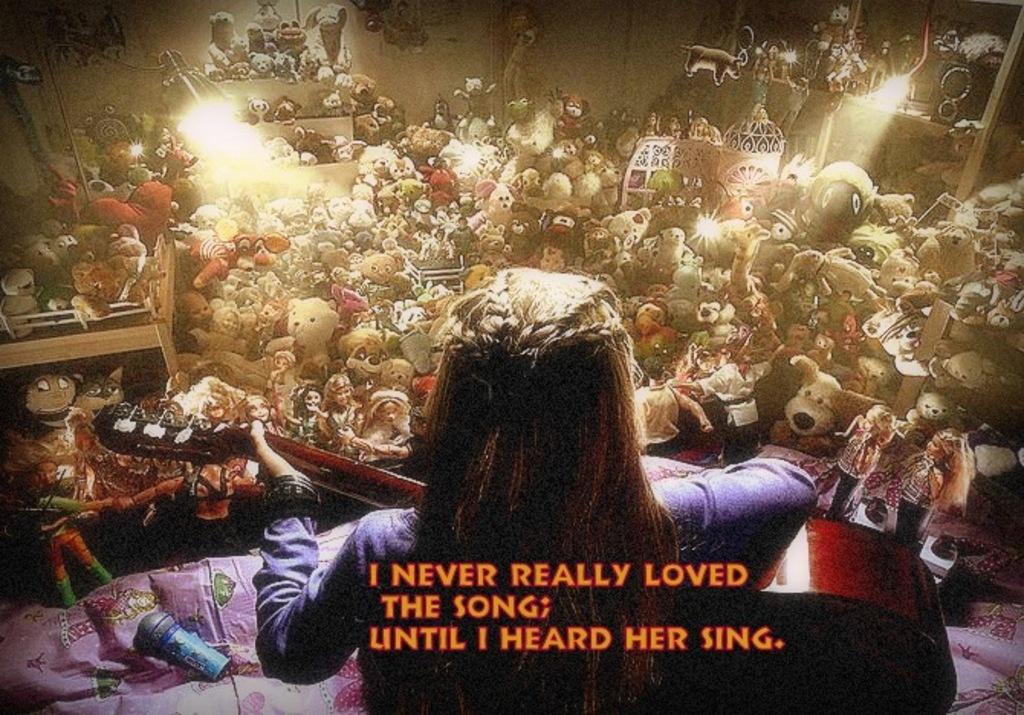How would you summarize this image in a sentence or two? In this picture a woman is holding a guitar in the hand. In the background I can see some toys and lights. Here I can see something written on the image. 